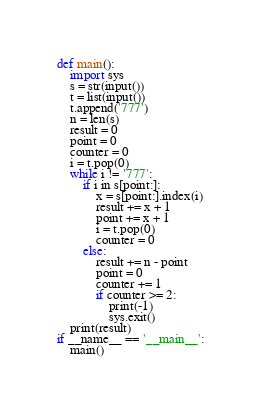Convert code to text. <code><loc_0><loc_0><loc_500><loc_500><_Python_>def main():
    import sys
    s = str(input())
    t = list(input())
    t.append('777')
    n = len(s)
    result = 0
    point = 0
    counter = 0
    i = t.pop(0)
    while i != '777':
        if i in s[point:]:
            x = s[point:].index(i)
            result += x + 1
            point += x + 1
            i = t.pop(0)
            counter = 0
        else:
            result += n - point
            point = 0
            counter += 1
            if counter >= 2:
                print(-1)
                sys.exit()
    print(result)
if __name__ == '__main__':
    main()</code> 